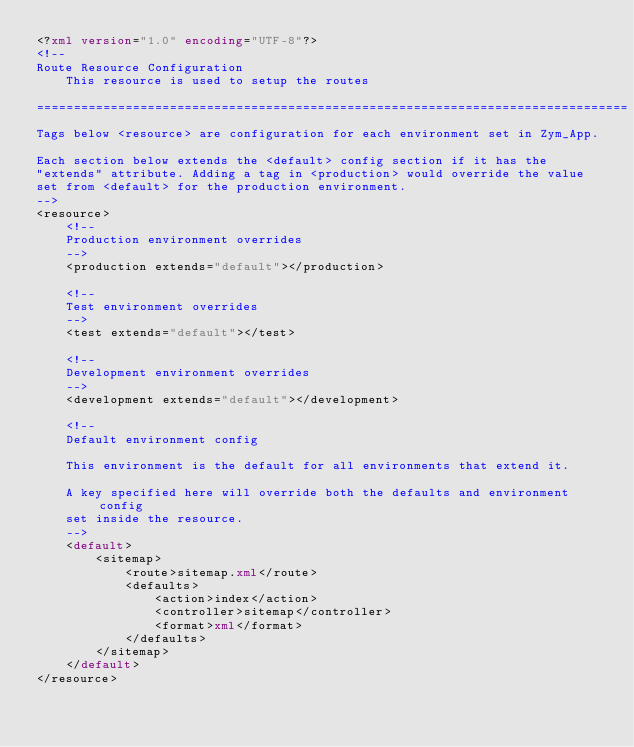Convert code to text. <code><loc_0><loc_0><loc_500><loc_500><_XML_><?xml version="1.0" encoding="UTF-8"?>
<!-- 
Route Resource Configuration
    This resource is used to setup the routes

================================================================================
Tags below <resource> are configuration for each environment set in Zym_App.

Each section below extends the <default> config section if it has the 
"extends" attribute. Adding a tag in <production> would override the value
set from <default> for the production environment.
-->
<resource>
    <!--
    Production environment overrides
    -->
    <production extends="default"></production>
    
    <!--
    Test environment overrides
    -->
    <test extends="default"></test>
    
    <!--
    Development environment overrides
    -->
    <development extends="default"></development>
    
    <!--
    Default environment config
    
    This environment is the default for all environments that extend it.
    
    A key specified here will override both the defaults and environment config
    set inside the resource.
    -->
    <default>
        <sitemap>
            <route>sitemap.xml</route>
            <defaults>
                <action>index</action>
                <controller>sitemap</controller>
                <format>xml</format>
            </defaults>
        </sitemap>
    </default>
</resource></code> 